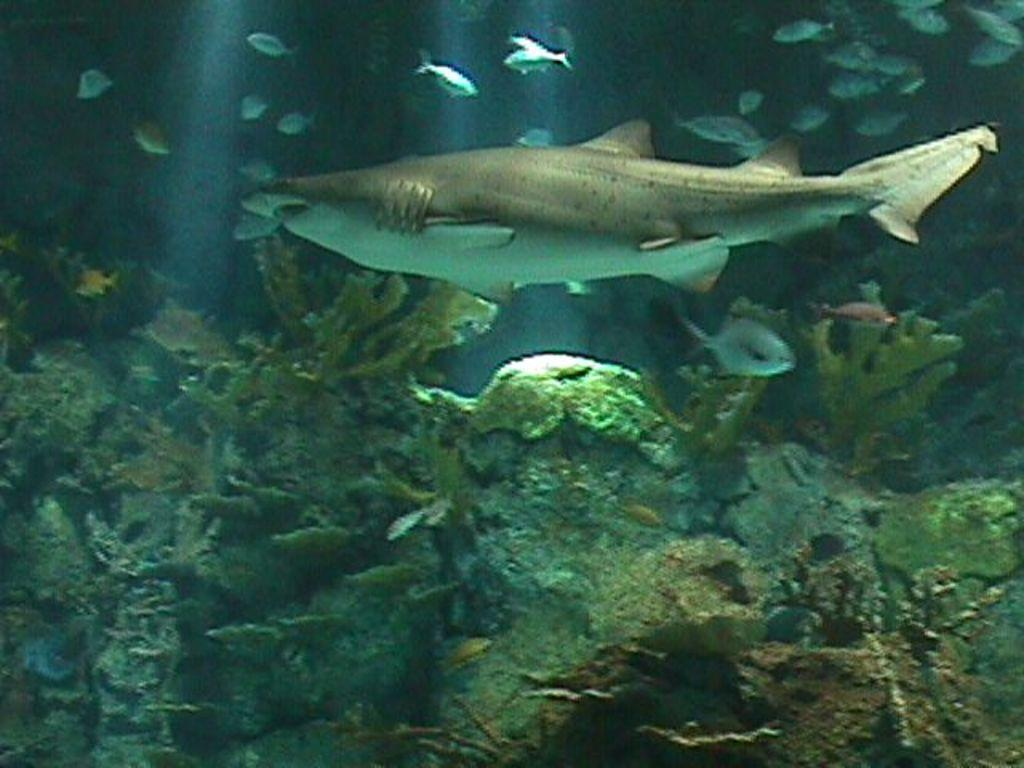What type of animals can be seen in the water in the image? There are fishes in the water in the image. What else can be seen at the bottom of the image? There are plants at the bottom of the image. What type of car can be seen driving through the water in the image? There is no car present in the image; it features fishes in the water and plants at the bottom. How does the crook use the scale to weigh the fishes in the image? There is no crook or scale present in the image; it only shows fishes in the water and plants at the bottom. 